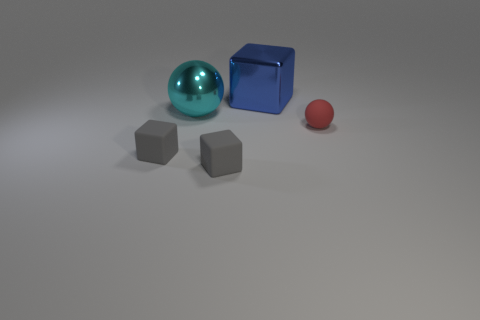The block that is both to the right of the big cyan thing and in front of the big blue object is made of what material?
Make the answer very short. Rubber. Do the large metal object in front of the large blue thing and the tiny thing that is on the right side of the large blue metal object have the same color?
Offer a very short reply. No. How many other objects are there of the same size as the cyan metallic thing?
Your response must be concise. 1. Are there any tiny gray blocks behind the small gray rubber thing that is on the left side of the big metal object in front of the big blue metal cube?
Offer a terse response. No. Does the object that is left of the big cyan metallic thing have the same material as the cyan thing?
Give a very brief answer. No. What is the color of the large thing that is the same shape as the small red rubber object?
Your answer should be compact. Cyan. Is there anything else that has the same shape as the big cyan thing?
Your response must be concise. Yes. Is the number of blue metallic cubes that are in front of the shiny cube the same as the number of large blue cubes?
Give a very brief answer. No. There is a big cyan sphere; are there any small red objects on the left side of it?
Provide a succinct answer. No. There is a gray object that is to the left of the ball that is behind the matte thing that is on the right side of the large blue thing; what is its size?
Keep it short and to the point. Small. 